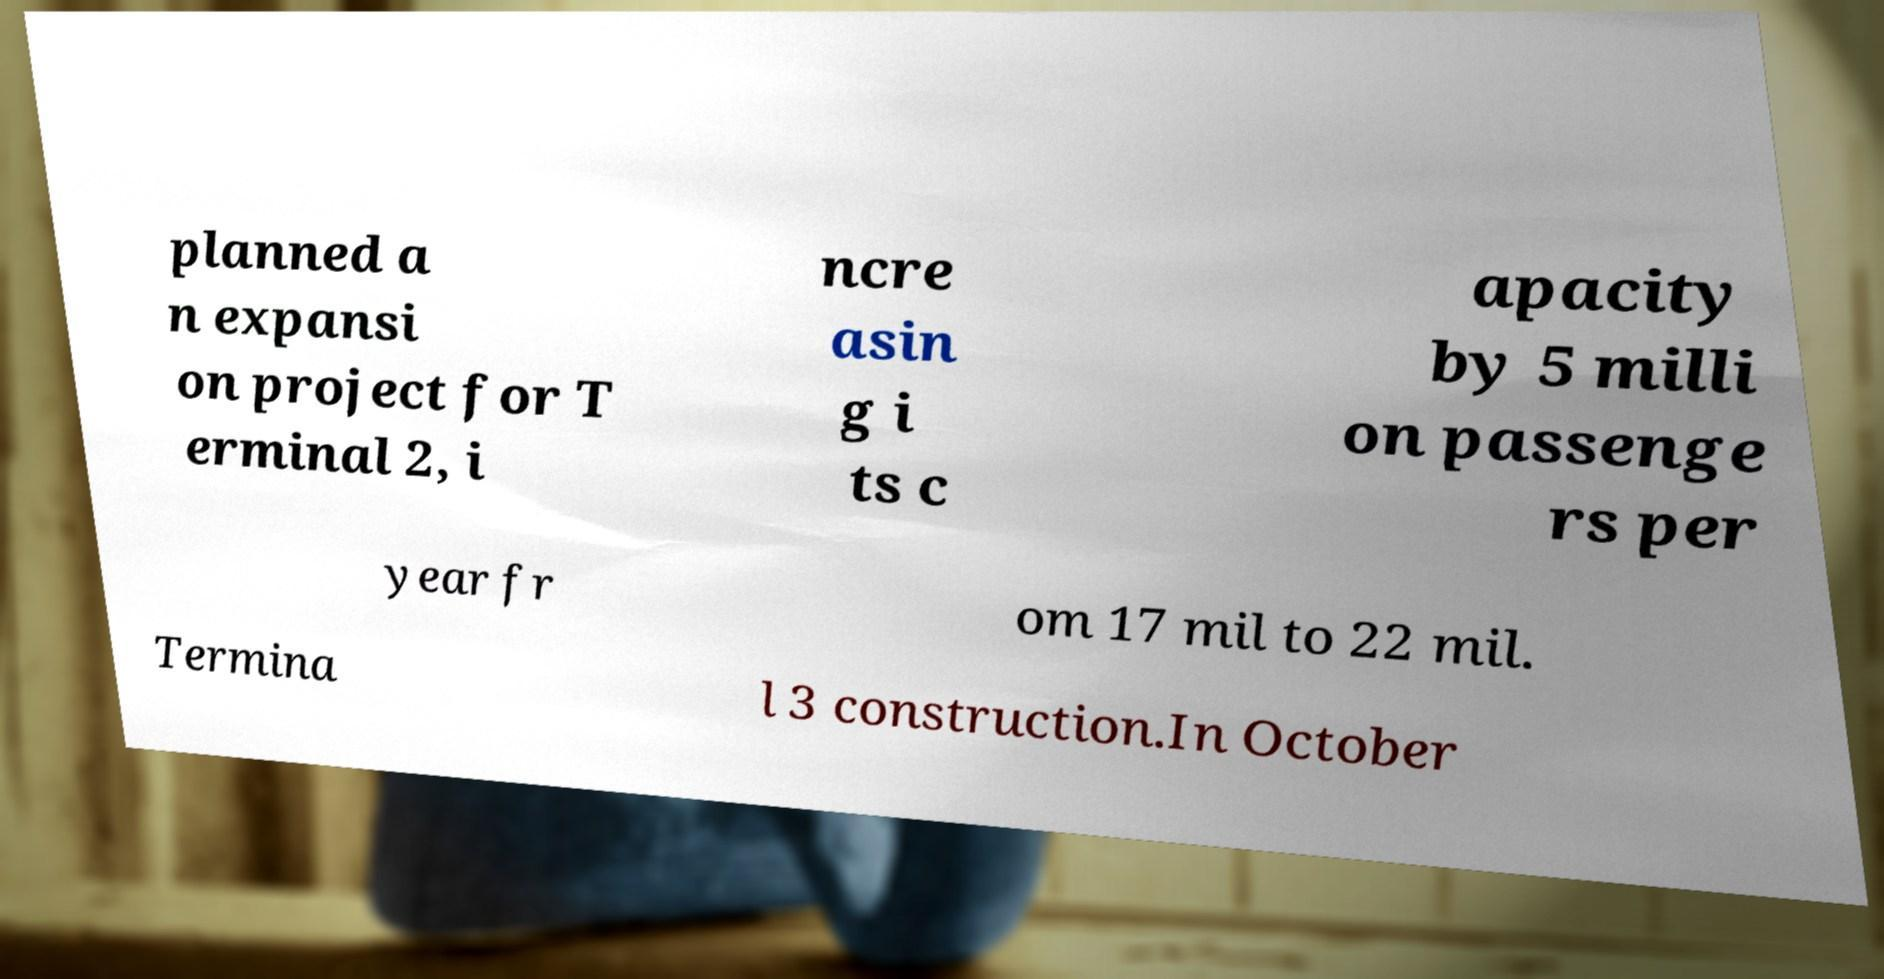Could you extract and type out the text from this image? planned a n expansi on project for T erminal 2, i ncre asin g i ts c apacity by 5 milli on passenge rs per year fr om 17 mil to 22 mil. Termina l 3 construction.In October 